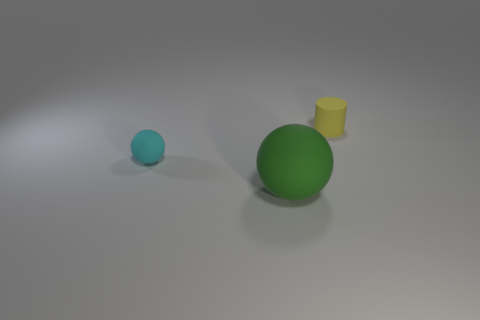There is a small object that is in front of the small yellow rubber object; how many spheres are right of it?
Give a very brief answer. 1. There is a thing that is right of the sphere in front of the small thing on the left side of the big green rubber object; what is its size?
Give a very brief answer. Small. The tiny rubber thing on the left side of the small object to the right of the cyan ball is what color?
Your answer should be compact. Cyan. What number of other things are the same color as the small cylinder?
Offer a very short reply. 0. What is the material of the tiny thing right of the ball in front of the tiny cyan rubber object?
Provide a short and direct response. Rubber. Is there a red sphere?
Keep it short and to the point. No. How big is the sphere that is in front of the tiny matte object to the left of the green matte thing?
Your response must be concise. Large. Are there more tiny cyan balls behind the large green ball than large green rubber spheres left of the small sphere?
Your answer should be very brief. Yes. How many cylinders are either cyan things or small gray objects?
Your answer should be very brief. 0. Are there any other things that have the same size as the green rubber object?
Give a very brief answer. No. 